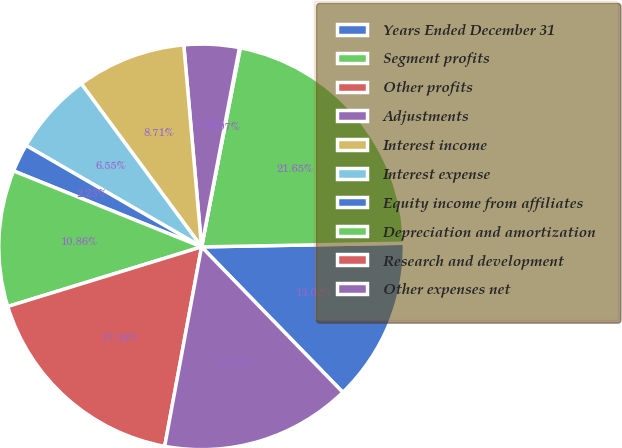<chart> <loc_0><loc_0><loc_500><loc_500><pie_chart><fcel>Years Ended December 31<fcel>Segment profits<fcel>Other profits<fcel>Adjustments<fcel>Interest income<fcel>Interest expense<fcel>Equity income from affiliates<fcel>Depreciation and amortization<fcel>Research and development<fcel>Other expenses net<nl><fcel>13.02%<fcel>21.65%<fcel>0.07%<fcel>4.39%<fcel>8.71%<fcel>6.55%<fcel>2.23%<fcel>10.86%<fcel>17.34%<fcel>15.18%<nl></chart> 